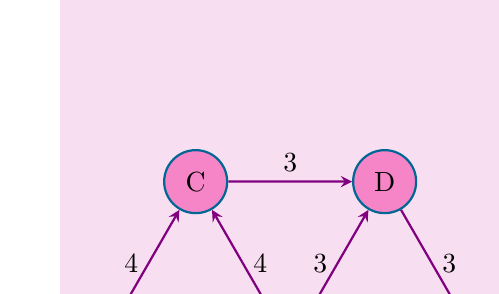Can you answer this question? Let's approach this step-by-step:

1) First, we need to understand the concept of a dominating set in graph theory. A dominating set is a subset of vertices such that every vertex in the graph is either in the set or adjacent to a vertex in the set.

2) In our case, we're looking for a dominating set where the "adjacency" is defined as being within a distance of 4.

3) Let's analyze each vertex:
   - A: Can reach B and C
   - B: Can reach A, C, D, and E
   - C: Can reach A, B, and D
   - D: Can reach B, C, and E
   - E: Can reach B and D

4) We can see that B can reach all other vertices within a distance of 4. Therefore, placing a facility at B would serve all neighborhoods.

5) To verify:
   - A to B: distance 5 (direct)
   - B to C: distance 4 (direct)
   - B to D: distance 3 (direct)
   - B to E: distance 4 (direct)

6) Since one facility at B can serve all neighborhoods, this is the minimum number of facilities needed.

Therefore, the optimal solution is to place one facility in neighborhood B.
Answer: 1 facility in neighborhood B 